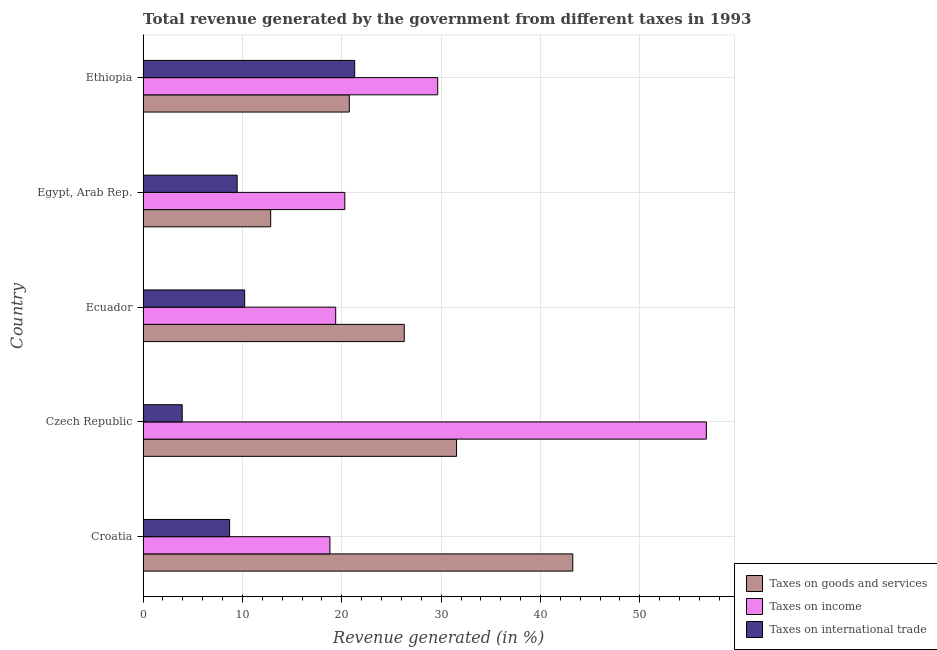How many different coloured bars are there?
Make the answer very short. 3. How many groups of bars are there?
Keep it short and to the point. 5. Are the number of bars per tick equal to the number of legend labels?
Provide a short and direct response. Yes. Are the number of bars on each tick of the Y-axis equal?
Your answer should be compact. Yes. How many bars are there on the 1st tick from the top?
Keep it short and to the point. 3. What is the label of the 4th group of bars from the top?
Your answer should be compact. Czech Republic. In how many cases, is the number of bars for a given country not equal to the number of legend labels?
Offer a very short reply. 0. What is the percentage of revenue generated by taxes on income in Ethiopia?
Your answer should be compact. 29.65. Across all countries, what is the maximum percentage of revenue generated by taxes on goods and services?
Your answer should be very brief. 43.25. Across all countries, what is the minimum percentage of revenue generated by tax on international trade?
Your response must be concise. 3.94. In which country was the percentage of revenue generated by tax on international trade maximum?
Offer a terse response. Ethiopia. In which country was the percentage of revenue generated by taxes on income minimum?
Keep it short and to the point. Croatia. What is the total percentage of revenue generated by taxes on goods and services in the graph?
Keep it short and to the point. 134.69. What is the difference between the percentage of revenue generated by taxes on income in Croatia and that in Egypt, Arab Rep.?
Your answer should be compact. -1.5. What is the difference between the percentage of revenue generated by taxes on income in Czech Republic and the percentage of revenue generated by taxes on goods and services in Ethiopia?
Your response must be concise. 35.93. What is the average percentage of revenue generated by tax on international trade per country?
Offer a terse response. 10.73. What is the difference between the percentage of revenue generated by tax on international trade and percentage of revenue generated by taxes on goods and services in Ecuador?
Ensure brevity in your answer.  -16.06. In how many countries, is the percentage of revenue generated by tax on international trade greater than 30 %?
Keep it short and to the point. 0. What is the ratio of the percentage of revenue generated by tax on international trade in Croatia to that in Ecuador?
Keep it short and to the point. 0.85. Is the percentage of revenue generated by taxes on goods and services in Ecuador less than that in Ethiopia?
Provide a succinct answer. No. What is the difference between the highest and the second highest percentage of revenue generated by tax on international trade?
Ensure brevity in your answer.  11.07. What is the difference between the highest and the lowest percentage of revenue generated by tax on international trade?
Keep it short and to the point. 17.36. Is the sum of the percentage of revenue generated by taxes on income in Croatia and Ethiopia greater than the maximum percentage of revenue generated by taxes on goods and services across all countries?
Keep it short and to the point. Yes. What does the 2nd bar from the top in Ecuador represents?
Offer a very short reply. Taxes on income. What does the 3rd bar from the bottom in Ecuador represents?
Your answer should be very brief. Taxes on international trade. How many bars are there?
Ensure brevity in your answer.  15. How many countries are there in the graph?
Provide a succinct answer. 5. What is the difference between two consecutive major ticks on the X-axis?
Offer a very short reply. 10. Does the graph contain any zero values?
Offer a terse response. No. Where does the legend appear in the graph?
Offer a terse response. Bottom right. How many legend labels are there?
Offer a very short reply. 3. What is the title of the graph?
Keep it short and to the point. Total revenue generated by the government from different taxes in 1993. What is the label or title of the X-axis?
Make the answer very short. Revenue generated (in %). What is the Revenue generated (in %) of Taxes on goods and services in Croatia?
Make the answer very short. 43.25. What is the Revenue generated (in %) of Taxes on income in Croatia?
Ensure brevity in your answer.  18.81. What is the Revenue generated (in %) in Taxes on international trade in Croatia?
Keep it short and to the point. 8.71. What is the Revenue generated (in %) of Taxes on goods and services in Czech Republic?
Provide a succinct answer. 31.55. What is the Revenue generated (in %) in Taxes on income in Czech Republic?
Give a very brief answer. 56.69. What is the Revenue generated (in %) of Taxes on international trade in Czech Republic?
Your answer should be compact. 3.94. What is the Revenue generated (in %) in Taxes on goods and services in Ecuador?
Give a very brief answer. 26.29. What is the Revenue generated (in %) in Taxes on income in Ecuador?
Your answer should be very brief. 19.39. What is the Revenue generated (in %) in Taxes on international trade in Ecuador?
Your answer should be very brief. 10.23. What is the Revenue generated (in %) in Taxes on goods and services in Egypt, Arab Rep.?
Offer a very short reply. 12.84. What is the Revenue generated (in %) of Taxes on income in Egypt, Arab Rep.?
Give a very brief answer. 20.3. What is the Revenue generated (in %) in Taxes on international trade in Egypt, Arab Rep.?
Provide a succinct answer. 9.47. What is the Revenue generated (in %) in Taxes on goods and services in Ethiopia?
Your response must be concise. 20.76. What is the Revenue generated (in %) in Taxes on income in Ethiopia?
Offer a very short reply. 29.65. What is the Revenue generated (in %) of Taxes on international trade in Ethiopia?
Keep it short and to the point. 21.3. Across all countries, what is the maximum Revenue generated (in %) in Taxes on goods and services?
Make the answer very short. 43.25. Across all countries, what is the maximum Revenue generated (in %) in Taxes on income?
Give a very brief answer. 56.69. Across all countries, what is the maximum Revenue generated (in %) of Taxes on international trade?
Offer a terse response. 21.3. Across all countries, what is the minimum Revenue generated (in %) of Taxes on goods and services?
Your response must be concise. 12.84. Across all countries, what is the minimum Revenue generated (in %) of Taxes on income?
Offer a very short reply. 18.81. Across all countries, what is the minimum Revenue generated (in %) in Taxes on international trade?
Ensure brevity in your answer.  3.94. What is the total Revenue generated (in %) of Taxes on goods and services in the graph?
Offer a terse response. 134.69. What is the total Revenue generated (in %) in Taxes on income in the graph?
Make the answer very short. 144.85. What is the total Revenue generated (in %) of Taxes on international trade in the graph?
Provide a short and direct response. 53.65. What is the difference between the Revenue generated (in %) in Taxes on goods and services in Croatia and that in Czech Republic?
Keep it short and to the point. 11.69. What is the difference between the Revenue generated (in %) in Taxes on income in Croatia and that in Czech Republic?
Ensure brevity in your answer.  -37.88. What is the difference between the Revenue generated (in %) in Taxes on international trade in Croatia and that in Czech Republic?
Keep it short and to the point. 4.77. What is the difference between the Revenue generated (in %) of Taxes on goods and services in Croatia and that in Ecuador?
Provide a short and direct response. 16.96. What is the difference between the Revenue generated (in %) of Taxes on income in Croatia and that in Ecuador?
Provide a short and direct response. -0.58. What is the difference between the Revenue generated (in %) of Taxes on international trade in Croatia and that in Ecuador?
Ensure brevity in your answer.  -1.51. What is the difference between the Revenue generated (in %) of Taxes on goods and services in Croatia and that in Egypt, Arab Rep.?
Provide a succinct answer. 30.4. What is the difference between the Revenue generated (in %) in Taxes on income in Croatia and that in Egypt, Arab Rep.?
Ensure brevity in your answer.  -1.49. What is the difference between the Revenue generated (in %) in Taxes on international trade in Croatia and that in Egypt, Arab Rep.?
Your answer should be very brief. -0.76. What is the difference between the Revenue generated (in %) in Taxes on goods and services in Croatia and that in Ethiopia?
Provide a short and direct response. 22.49. What is the difference between the Revenue generated (in %) in Taxes on income in Croatia and that in Ethiopia?
Your answer should be compact. -10.85. What is the difference between the Revenue generated (in %) of Taxes on international trade in Croatia and that in Ethiopia?
Provide a succinct answer. -12.59. What is the difference between the Revenue generated (in %) of Taxes on goods and services in Czech Republic and that in Ecuador?
Your answer should be very brief. 5.27. What is the difference between the Revenue generated (in %) in Taxes on income in Czech Republic and that in Ecuador?
Your answer should be compact. 37.3. What is the difference between the Revenue generated (in %) in Taxes on international trade in Czech Republic and that in Ecuador?
Give a very brief answer. -6.28. What is the difference between the Revenue generated (in %) of Taxes on goods and services in Czech Republic and that in Egypt, Arab Rep.?
Ensure brevity in your answer.  18.71. What is the difference between the Revenue generated (in %) of Taxes on income in Czech Republic and that in Egypt, Arab Rep.?
Your response must be concise. 36.39. What is the difference between the Revenue generated (in %) of Taxes on international trade in Czech Republic and that in Egypt, Arab Rep.?
Your answer should be very brief. -5.53. What is the difference between the Revenue generated (in %) of Taxes on goods and services in Czech Republic and that in Ethiopia?
Your answer should be very brief. 10.8. What is the difference between the Revenue generated (in %) in Taxes on income in Czech Republic and that in Ethiopia?
Your answer should be very brief. 27.04. What is the difference between the Revenue generated (in %) in Taxes on international trade in Czech Republic and that in Ethiopia?
Your response must be concise. -17.36. What is the difference between the Revenue generated (in %) in Taxes on goods and services in Ecuador and that in Egypt, Arab Rep.?
Offer a very short reply. 13.44. What is the difference between the Revenue generated (in %) in Taxes on income in Ecuador and that in Egypt, Arab Rep.?
Your answer should be very brief. -0.92. What is the difference between the Revenue generated (in %) of Taxes on international trade in Ecuador and that in Egypt, Arab Rep.?
Give a very brief answer. 0.76. What is the difference between the Revenue generated (in %) in Taxes on goods and services in Ecuador and that in Ethiopia?
Your answer should be very brief. 5.53. What is the difference between the Revenue generated (in %) of Taxes on income in Ecuador and that in Ethiopia?
Make the answer very short. -10.27. What is the difference between the Revenue generated (in %) of Taxes on international trade in Ecuador and that in Ethiopia?
Your response must be concise. -11.07. What is the difference between the Revenue generated (in %) of Taxes on goods and services in Egypt, Arab Rep. and that in Ethiopia?
Provide a succinct answer. -7.91. What is the difference between the Revenue generated (in %) of Taxes on income in Egypt, Arab Rep. and that in Ethiopia?
Keep it short and to the point. -9.35. What is the difference between the Revenue generated (in %) in Taxes on international trade in Egypt, Arab Rep. and that in Ethiopia?
Provide a succinct answer. -11.83. What is the difference between the Revenue generated (in %) of Taxes on goods and services in Croatia and the Revenue generated (in %) of Taxes on income in Czech Republic?
Provide a short and direct response. -13.44. What is the difference between the Revenue generated (in %) of Taxes on goods and services in Croatia and the Revenue generated (in %) of Taxes on international trade in Czech Republic?
Provide a succinct answer. 39.31. What is the difference between the Revenue generated (in %) in Taxes on income in Croatia and the Revenue generated (in %) in Taxes on international trade in Czech Republic?
Offer a terse response. 14.87. What is the difference between the Revenue generated (in %) in Taxes on goods and services in Croatia and the Revenue generated (in %) in Taxes on income in Ecuador?
Give a very brief answer. 23.86. What is the difference between the Revenue generated (in %) in Taxes on goods and services in Croatia and the Revenue generated (in %) in Taxes on international trade in Ecuador?
Provide a short and direct response. 33.02. What is the difference between the Revenue generated (in %) of Taxes on income in Croatia and the Revenue generated (in %) of Taxes on international trade in Ecuador?
Your response must be concise. 8.58. What is the difference between the Revenue generated (in %) of Taxes on goods and services in Croatia and the Revenue generated (in %) of Taxes on income in Egypt, Arab Rep.?
Offer a very short reply. 22.94. What is the difference between the Revenue generated (in %) in Taxes on goods and services in Croatia and the Revenue generated (in %) in Taxes on international trade in Egypt, Arab Rep.?
Provide a succinct answer. 33.78. What is the difference between the Revenue generated (in %) in Taxes on income in Croatia and the Revenue generated (in %) in Taxes on international trade in Egypt, Arab Rep.?
Offer a terse response. 9.34. What is the difference between the Revenue generated (in %) of Taxes on goods and services in Croatia and the Revenue generated (in %) of Taxes on income in Ethiopia?
Keep it short and to the point. 13.59. What is the difference between the Revenue generated (in %) in Taxes on goods and services in Croatia and the Revenue generated (in %) in Taxes on international trade in Ethiopia?
Keep it short and to the point. 21.95. What is the difference between the Revenue generated (in %) in Taxes on income in Croatia and the Revenue generated (in %) in Taxes on international trade in Ethiopia?
Your answer should be compact. -2.49. What is the difference between the Revenue generated (in %) in Taxes on goods and services in Czech Republic and the Revenue generated (in %) in Taxes on income in Ecuador?
Offer a terse response. 12.17. What is the difference between the Revenue generated (in %) of Taxes on goods and services in Czech Republic and the Revenue generated (in %) of Taxes on international trade in Ecuador?
Your answer should be compact. 21.33. What is the difference between the Revenue generated (in %) of Taxes on income in Czech Republic and the Revenue generated (in %) of Taxes on international trade in Ecuador?
Make the answer very short. 46.47. What is the difference between the Revenue generated (in %) of Taxes on goods and services in Czech Republic and the Revenue generated (in %) of Taxes on income in Egypt, Arab Rep.?
Your answer should be very brief. 11.25. What is the difference between the Revenue generated (in %) in Taxes on goods and services in Czech Republic and the Revenue generated (in %) in Taxes on international trade in Egypt, Arab Rep.?
Your answer should be compact. 22.09. What is the difference between the Revenue generated (in %) in Taxes on income in Czech Republic and the Revenue generated (in %) in Taxes on international trade in Egypt, Arab Rep.?
Your answer should be very brief. 47.22. What is the difference between the Revenue generated (in %) of Taxes on goods and services in Czech Republic and the Revenue generated (in %) of Taxes on income in Ethiopia?
Provide a succinct answer. 1.9. What is the difference between the Revenue generated (in %) in Taxes on goods and services in Czech Republic and the Revenue generated (in %) in Taxes on international trade in Ethiopia?
Provide a short and direct response. 10.25. What is the difference between the Revenue generated (in %) in Taxes on income in Czech Republic and the Revenue generated (in %) in Taxes on international trade in Ethiopia?
Your answer should be compact. 35.39. What is the difference between the Revenue generated (in %) in Taxes on goods and services in Ecuador and the Revenue generated (in %) in Taxes on income in Egypt, Arab Rep.?
Your response must be concise. 5.98. What is the difference between the Revenue generated (in %) of Taxes on goods and services in Ecuador and the Revenue generated (in %) of Taxes on international trade in Egypt, Arab Rep.?
Provide a succinct answer. 16.82. What is the difference between the Revenue generated (in %) of Taxes on income in Ecuador and the Revenue generated (in %) of Taxes on international trade in Egypt, Arab Rep.?
Make the answer very short. 9.92. What is the difference between the Revenue generated (in %) in Taxes on goods and services in Ecuador and the Revenue generated (in %) in Taxes on income in Ethiopia?
Give a very brief answer. -3.37. What is the difference between the Revenue generated (in %) of Taxes on goods and services in Ecuador and the Revenue generated (in %) of Taxes on international trade in Ethiopia?
Offer a terse response. 4.99. What is the difference between the Revenue generated (in %) of Taxes on income in Ecuador and the Revenue generated (in %) of Taxes on international trade in Ethiopia?
Provide a short and direct response. -1.91. What is the difference between the Revenue generated (in %) in Taxes on goods and services in Egypt, Arab Rep. and the Revenue generated (in %) in Taxes on income in Ethiopia?
Make the answer very short. -16.81. What is the difference between the Revenue generated (in %) in Taxes on goods and services in Egypt, Arab Rep. and the Revenue generated (in %) in Taxes on international trade in Ethiopia?
Make the answer very short. -8.46. What is the difference between the Revenue generated (in %) in Taxes on income in Egypt, Arab Rep. and the Revenue generated (in %) in Taxes on international trade in Ethiopia?
Your response must be concise. -1. What is the average Revenue generated (in %) of Taxes on goods and services per country?
Provide a short and direct response. 26.94. What is the average Revenue generated (in %) in Taxes on income per country?
Your response must be concise. 28.97. What is the average Revenue generated (in %) of Taxes on international trade per country?
Ensure brevity in your answer.  10.73. What is the difference between the Revenue generated (in %) of Taxes on goods and services and Revenue generated (in %) of Taxes on income in Croatia?
Make the answer very short. 24.44. What is the difference between the Revenue generated (in %) of Taxes on goods and services and Revenue generated (in %) of Taxes on international trade in Croatia?
Give a very brief answer. 34.54. What is the difference between the Revenue generated (in %) in Taxes on income and Revenue generated (in %) in Taxes on international trade in Croatia?
Your answer should be compact. 10.1. What is the difference between the Revenue generated (in %) in Taxes on goods and services and Revenue generated (in %) in Taxes on income in Czech Republic?
Your response must be concise. -25.14. What is the difference between the Revenue generated (in %) in Taxes on goods and services and Revenue generated (in %) in Taxes on international trade in Czech Republic?
Your response must be concise. 27.61. What is the difference between the Revenue generated (in %) in Taxes on income and Revenue generated (in %) in Taxes on international trade in Czech Republic?
Make the answer very short. 52.75. What is the difference between the Revenue generated (in %) of Taxes on goods and services and Revenue generated (in %) of Taxes on income in Ecuador?
Offer a terse response. 6.9. What is the difference between the Revenue generated (in %) of Taxes on goods and services and Revenue generated (in %) of Taxes on international trade in Ecuador?
Offer a very short reply. 16.06. What is the difference between the Revenue generated (in %) of Taxes on income and Revenue generated (in %) of Taxes on international trade in Ecuador?
Offer a very short reply. 9.16. What is the difference between the Revenue generated (in %) in Taxes on goods and services and Revenue generated (in %) in Taxes on income in Egypt, Arab Rep.?
Keep it short and to the point. -7.46. What is the difference between the Revenue generated (in %) in Taxes on goods and services and Revenue generated (in %) in Taxes on international trade in Egypt, Arab Rep.?
Give a very brief answer. 3.38. What is the difference between the Revenue generated (in %) in Taxes on income and Revenue generated (in %) in Taxes on international trade in Egypt, Arab Rep.?
Your response must be concise. 10.83. What is the difference between the Revenue generated (in %) in Taxes on goods and services and Revenue generated (in %) in Taxes on income in Ethiopia?
Ensure brevity in your answer.  -8.9. What is the difference between the Revenue generated (in %) of Taxes on goods and services and Revenue generated (in %) of Taxes on international trade in Ethiopia?
Make the answer very short. -0.54. What is the difference between the Revenue generated (in %) in Taxes on income and Revenue generated (in %) in Taxes on international trade in Ethiopia?
Your response must be concise. 8.35. What is the ratio of the Revenue generated (in %) of Taxes on goods and services in Croatia to that in Czech Republic?
Provide a short and direct response. 1.37. What is the ratio of the Revenue generated (in %) of Taxes on income in Croatia to that in Czech Republic?
Your response must be concise. 0.33. What is the ratio of the Revenue generated (in %) of Taxes on international trade in Croatia to that in Czech Republic?
Offer a terse response. 2.21. What is the ratio of the Revenue generated (in %) in Taxes on goods and services in Croatia to that in Ecuador?
Your answer should be very brief. 1.65. What is the ratio of the Revenue generated (in %) of Taxes on income in Croatia to that in Ecuador?
Your answer should be compact. 0.97. What is the ratio of the Revenue generated (in %) of Taxes on international trade in Croatia to that in Ecuador?
Ensure brevity in your answer.  0.85. What is the ratio of the Revenue generated (in %) of Taxes on goods and services in Croatia to that in Egypt, Arab Rep.?
Your answer should be very brief. 3.37. What is the ratio of the Revenue generated (in %) of Taxes on income in Croatia to that in Egypt, Arab Rep.?
Provide a short and direct response. 0.93. What is the ratio of the Revenue generated (in %) in Taxes on international trade in Croatia to that in Egypt, Arab Rep.?
Your answer should be compact. 0.92. What is the ratio of the Revenue generated (in %) of Taxes on goods and services in Croatia to that in Ethiopia?
Give a very brief answer. 2.08. What is the ratio of the Revenue generated (in %) of Taxes on income in Croatia to that in Ethiopia?
Ensure brevity in your answer.  0.63. What is the ratio of the Revenue generated (in %) in Taxes on international trade in Croatia to that in Ethiopia?
Your response must be concise. 0.41. What is the ratio of the Revenue generated (in %) in Taxes on goods and services in Czech Republic to that in Ecuador?
Make the answer very short. 1.2. What is the ratio of the Revenue generated (in %) in Taxes on income in Czech Republic to that in Ecuador?
Give a very brief answer. 2.92. What is the ratio of the Revenue generated (in %) in Taxes on international trade in Czech Republic to that in Ecuador?
Your answer should be very brief. 0.39. What is the ratio of the Revenue generated (in %) in Taxes on goods and services in Czech Republic to that in Egypt, Arab Rep.?
Provide a short and direct response. 2.46. What is the ratio of the Revenue generated (in %) in Taxes on income in Czech Republic to that in Egypt, Arab Rep.?
Make the answer very short. 2.79. What is the ratio of the Revenue generated (in %) of Taxes on international trade in Czech Republic to that in Egypt, Arab Rep.?
Offer a very short reply. 0.42. What is the ratio of the Revenue generated (in %) of Taxes on goods and services in Czech Republic to that in Ethiopia?
Offer a very short reply. 1.52. What is the ratio of the Revenue generated (in %) of Taxes on income in Czech Republic to that in Ethiopia?
Your response must be concise. 1.91. What is the ratio of the Revenue generated (in %) of Taxes on international trade in Czech Republic to that in Ethiopia?
Your answer should be very brief. 0.18. What is the ratio of the Revenue generated (in %) in Taxes on goods and services in Ecuador to that in Egypt, Arab Rep.?
Your answer should be very brief. 2.05. What is the ratio of the Revenue generated (in %) in Taxes on income in Ecuador to that in Egypt, Arab Rep.?
Your answer should be very brief. 0.95. What is the ratio of the Revenue generated (in %) of Taxes on international trade in Ecuador to that in Egypt, Arab Rep.?
Provide a succinct answer. 1.08. What is the ratio of the Revenue generated (in %) in Taxes on goods and services in Ecuador to that in Ethiopia?
Offer a terse response. 1.27. What is the ratio of the Revenue generated (in %) in Taxes on income in Ecuador to that in Ethiopia?
Your answer should be very brief. 0.65. What is the ratio of the Revenue generated (in %) of Taxes on international trade in Ecuador to that in Ethiopia?
Keep it short and to the point. 0.48. What is the ratio of the Revenue generated (in %) of Taxes on goods and services in Egypt, Arab Rep. to that in Ethiopia?
Give a very brief answer. 0.62. What is the ratio of the Revenue generated (in %) in Taxes on income in Egypt, Arab Rep. to that in Ethiopia?
Provide a short and direct response. 0.68. What is the ratio of the Revenue generated (in %) in Taxes on international trade in Egypt, Arab Rep. to that in Ethiopia?
Ensure brevity in your answer.  0.44. What is the difference between the highest and the second highest Revenue generated (in %) of Taxes on goods and services?
Your answer should be very brief. 11.69. What is the difference between the highest and the second highest Revenue generated (in %) in Taxes on income?
Make the answer very short. 27.04. What is the difference between the highest and the second highest Revenue generated (in %) of Taxes on international trade?
Ensure brevity in your answer.  11.07. What is the difference between the highest and the lowest Revenue generated (in %) in Taxes on goods and services?
Offer a very short reply. 30.4. What is the difference between the highest and the lowest Revenue generated (in %) of Taxes on income?
Your answer should be compact. 37.88. What is the difference between the highest and the lowest Revenue generated (in %) of Taxes on international trade?
Offer a very short reply. 17.36. 